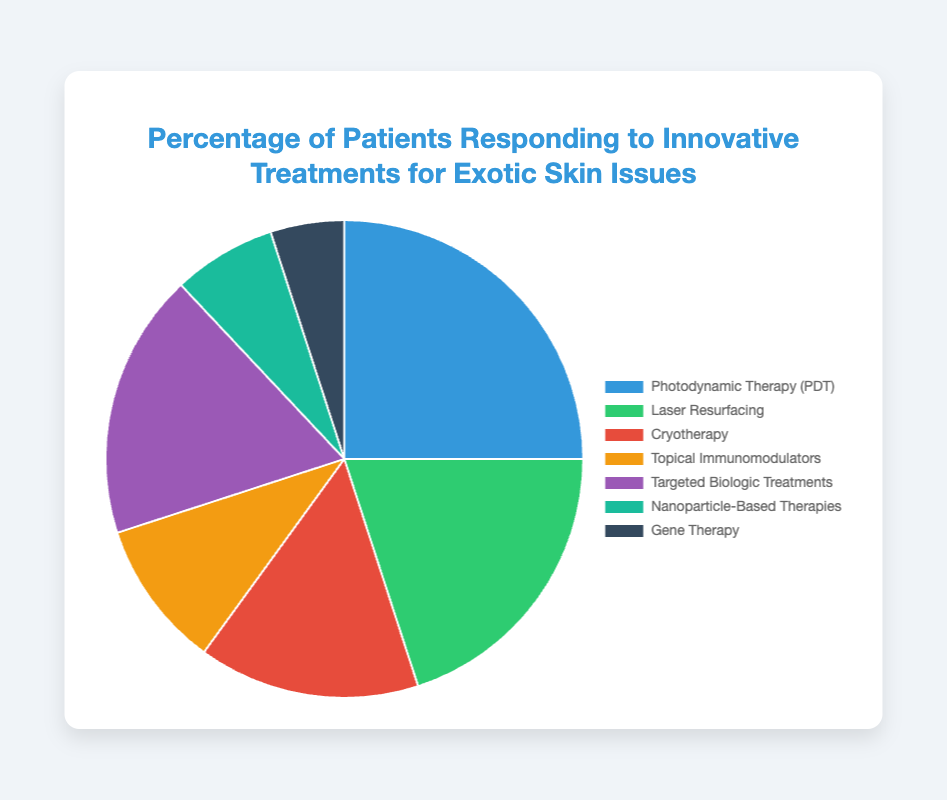Which treatment has the highest percentage of patients responding? The figure shows a pie chart with segments representing percentages of patients responding to different treatments. The largest segment corresponds to "Photodynamic Therapy (PDT)", which has 25%.
Answer: Photodynamic Therapy (PDT) Which treatment has the lowest percentage of patients responding? The pie chart's segments vary in size, representing different percentage values. The smallest segment, which represents 5%, corresponds to "Gene Therapy".
Answer: Gene Therapy What is the combined percentage of patients responding to Photodynamic Therapy (PDT) and Laser Resurfacing? According to the pie chart, Photodynamic Therapy (PDT) accounts for 25%, and Laser Resurfacing accounts for 20%. Adding these together, we get 25% + 20% = 45%.
Answer: 45% Which treatment is more effective: Targeted Biologic Treatments or Cryotherapy? Targeted Biologic Treatments are shown to have an 18% patient response rate, whereas Cryotherapy has a 15% response rate. Thus, Targeted Biologic Treatments are more effective.
Answer: Targeted Biologic Treatments What is the difference in the percentage of patients responding between Topical Immunomodulators and Nanoparticle-Based Therapies? Topical Immunomodulators have a response rate of 10%, and Nanoparticle-Based Therapies have a 7% response rate. The difference between these percentages is 10% - 7% = 3%.
Answer: 3% Which treatment is represented by the green segment in the pie chart? The pie chart uses different colors to represent each treatment. Referring to the chart, the green segment corresponds to "Laser Resurfacing".
Answer: Laser Resurfacing What is the average percentage of patients responding across all treatments? Sum all the percentages: 25 + 20 + 15 + 10 + 18 + 7 + 5 = 100. There are 7 treatments, so the average is 100 / 7 ≈ 14.29%.
Answer: 14.29% Are there more patients responding to Laser Resurfacing or Topical Immunomodulators? The pie chart shows Laser Resurfacing with 20% response and Topical Immunomodulators with 10%. Thus, Laser Resurfacing has more patients responding.
Answer: Laser Resurfacing What percentage of patients responded to treatments other than Photodynamic Therapy (PDT)? Exclude Photodynamic Therapy (PDT) which has 25%. The sum of percentages for other treatments is 20 + 15 + 10 + 18 + 7 + 5 = 75.
Answer: 75% Which treatments have a response rate of 15% or higher? Treatments meeting this criterion include Photodynamic Therapy (PDT) with 25%, Laser Resurfacing with 20%, Cryotherapy with 15%, and Targeted Biologic Treatments with 18%.
Answer: Photodynamic Therapy (PDT), Laser Resurfacing, Cryotherapy, Targeted Biologic Treatments 